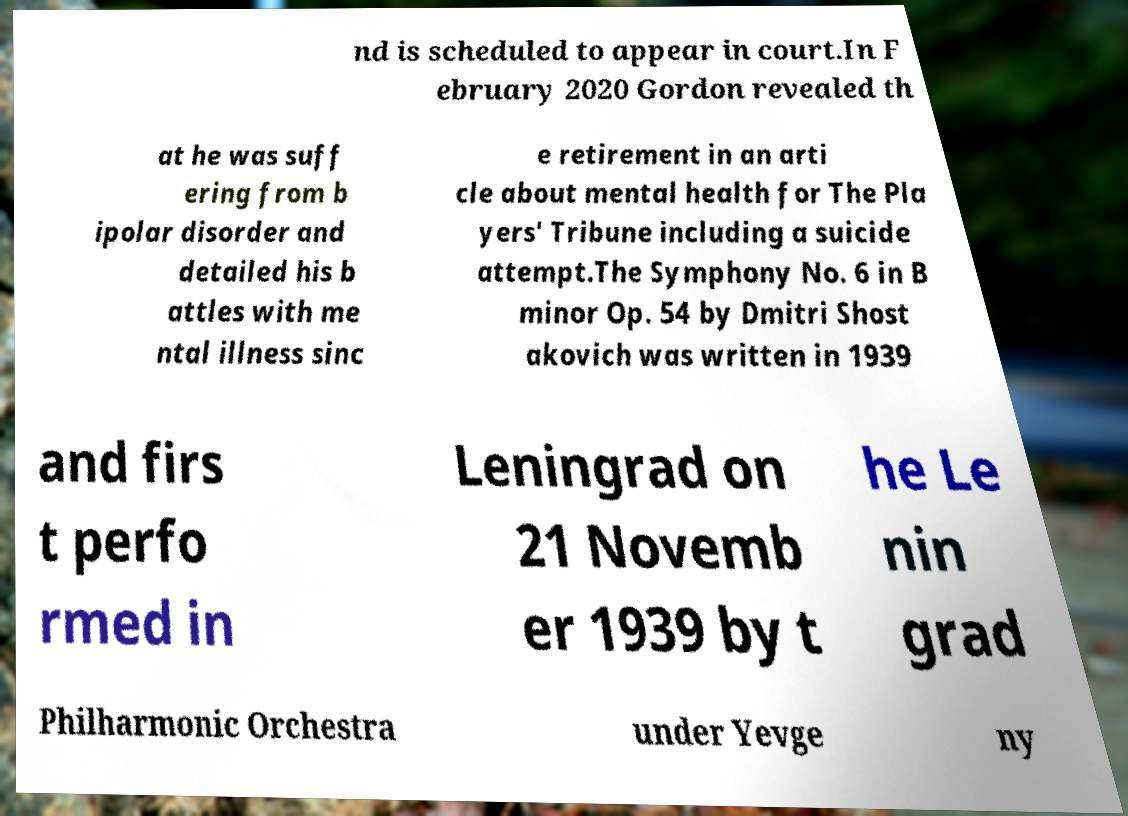Could you assist in decoding the text presented in this image and type it out clearly? nd is scheduled to appear in court.In F ebruary 2020 Gordon revealed th at he was suff ering from b ipolar disorder and detailed his b attles with me ntal illness sinc e retirement in an arti cle about mental health for The Pla yers' Tribune including a suicide attempt.The Symphony No. 6 in B minor Op. 54 by Dmitri Shost akovich was written in 1939 and firs t perfo rmed in Leningrad on 21 Novemb er 1939 by t he Le nin grad Philharmonic Orchestra under Yevge ny 